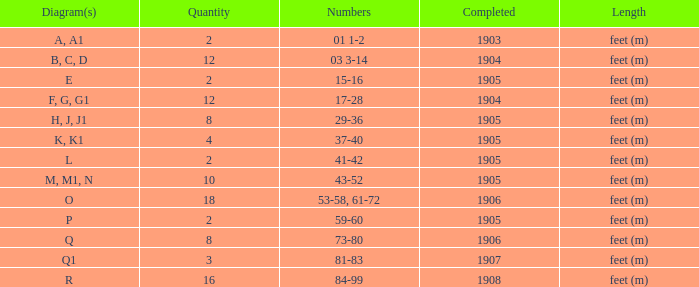What are the numerals for the object concluded earlier than 1904? 01 1-2. 